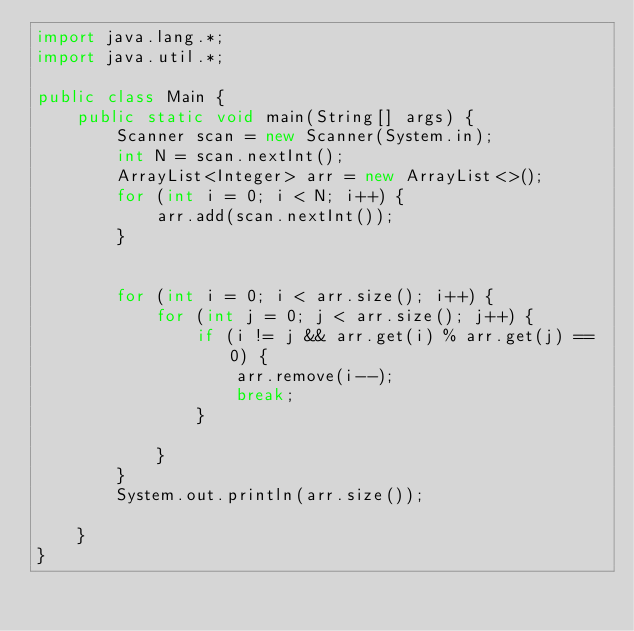<code> <loc_0><loc_0><loc_500><loc_500><_Java_>import java.lang.*;
import java.util.*;

public class Main {
    public static void main(String[] args) {
        Scanner scan = new Scanner(System.in);
        int N = scan.nextInt();
        ArrayList<Integer> arr = new ArrayList<>();
        for (int i = 0; i < N; i++) {
            arr.add(scan.nextInt());
        }


        for (int i = 0; i < arr.size(); i++) {
            for (int j = 0; j < arr.size(); j++) {
                if (i != j && arr.get(i) % arr.get(j) == 0) {
                    arr.remove(i--);
                    break;
                }

            }
        }
        System.out.println(arr.size());

    }
}</code> 